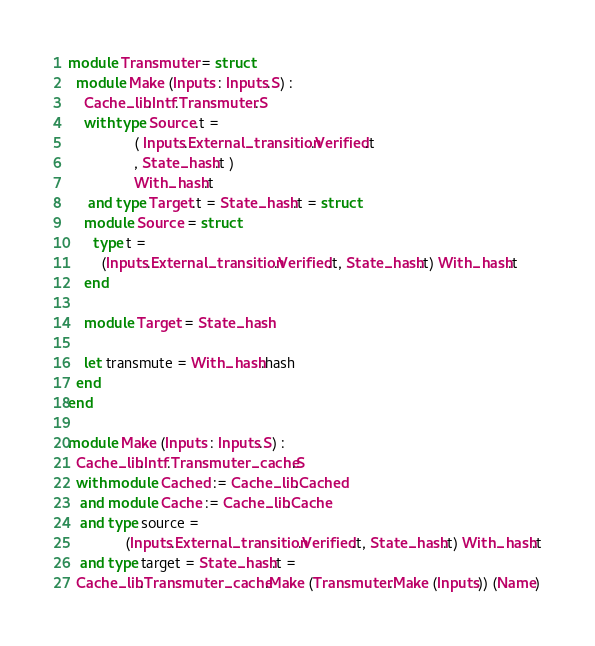<code> <loc_0><loc_0><loc_500><loc_500><_OCaml_>
module Transmuter = struct
  module Make (Inputs : Inputs.S) :
    Cache_lib.Intf.Transmuter.S
    with type Source.t =
                ( Inputs.External_transition.Verified.t
                , State_hash.t )
                With_hash.t
     and type Target.t = State_hash.t = struct
    module Source = struct
      type t =
        (Inputs.External_transition.Verified.t, State_hash.t) With_hash.t
    end

    module Target = State_hash

    let transmute = With_hash.hash
  end
end

module Make (Inputs : Inputs.S) :
  Cache_lib.Intf.Transmuter_cache.S
  with module Cached := Cache_lib.Cached
   and module Cache := Cache_lib.Cache
   and type source =
              (Inputs.External_transition.Verified.t, State_hash.t) With_hash.t
   and type target = State_hash.t =
  Cache_lib.Transmuter_cache.Make (Transmuter.Make (Inputs)) (Name)
</code> 